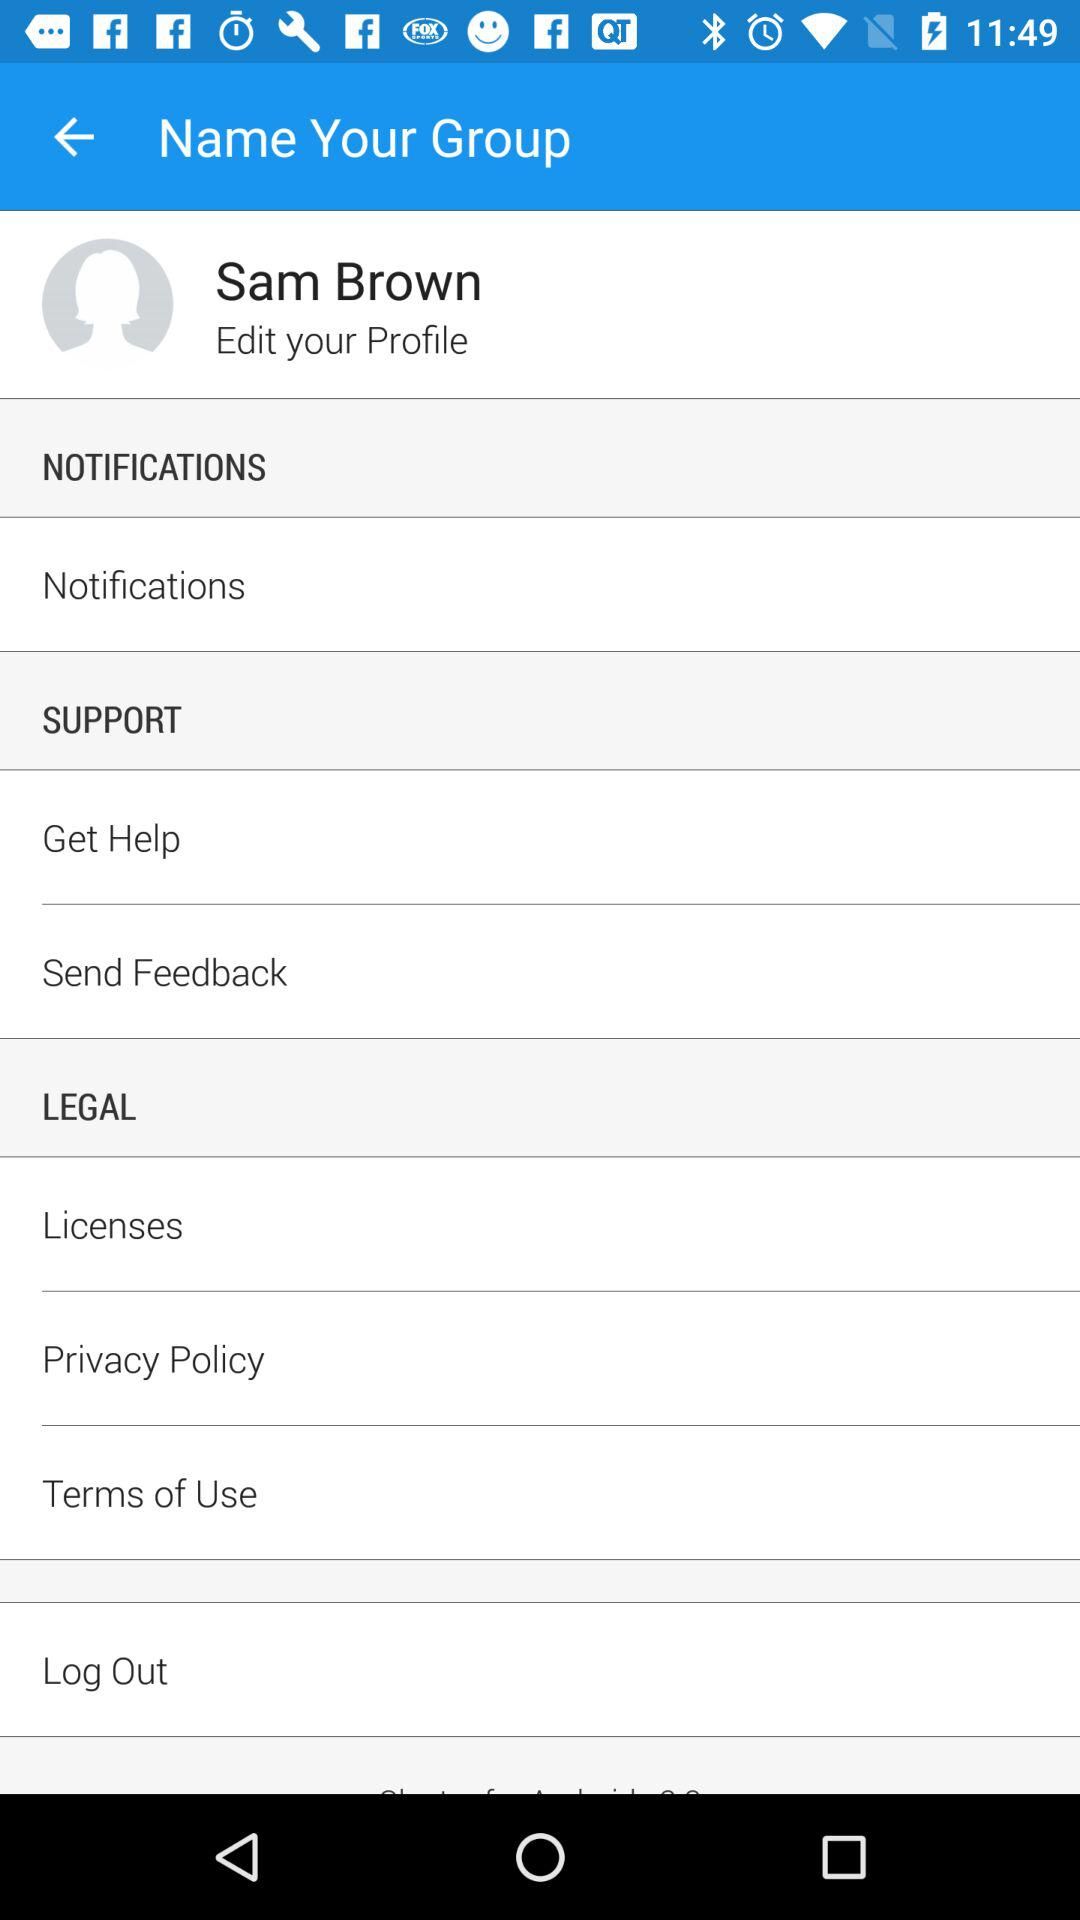What is the user name? The user name is Sam Brown. 